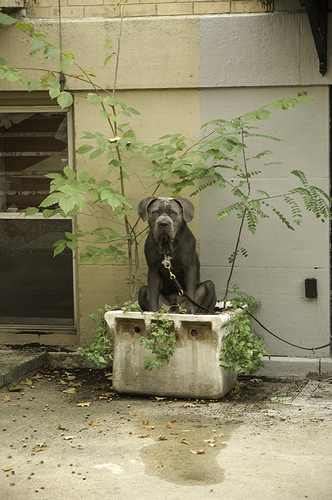<image>
Is there a dog next to the tree? Yes. The dog is positioned adjacent to the tree, located nearby in the same general area. Where is the dog in relation to the plant? Is it to the left of the plant? Yes. From this viewpoint, the dog is positioned to the left side relative to the plant. 